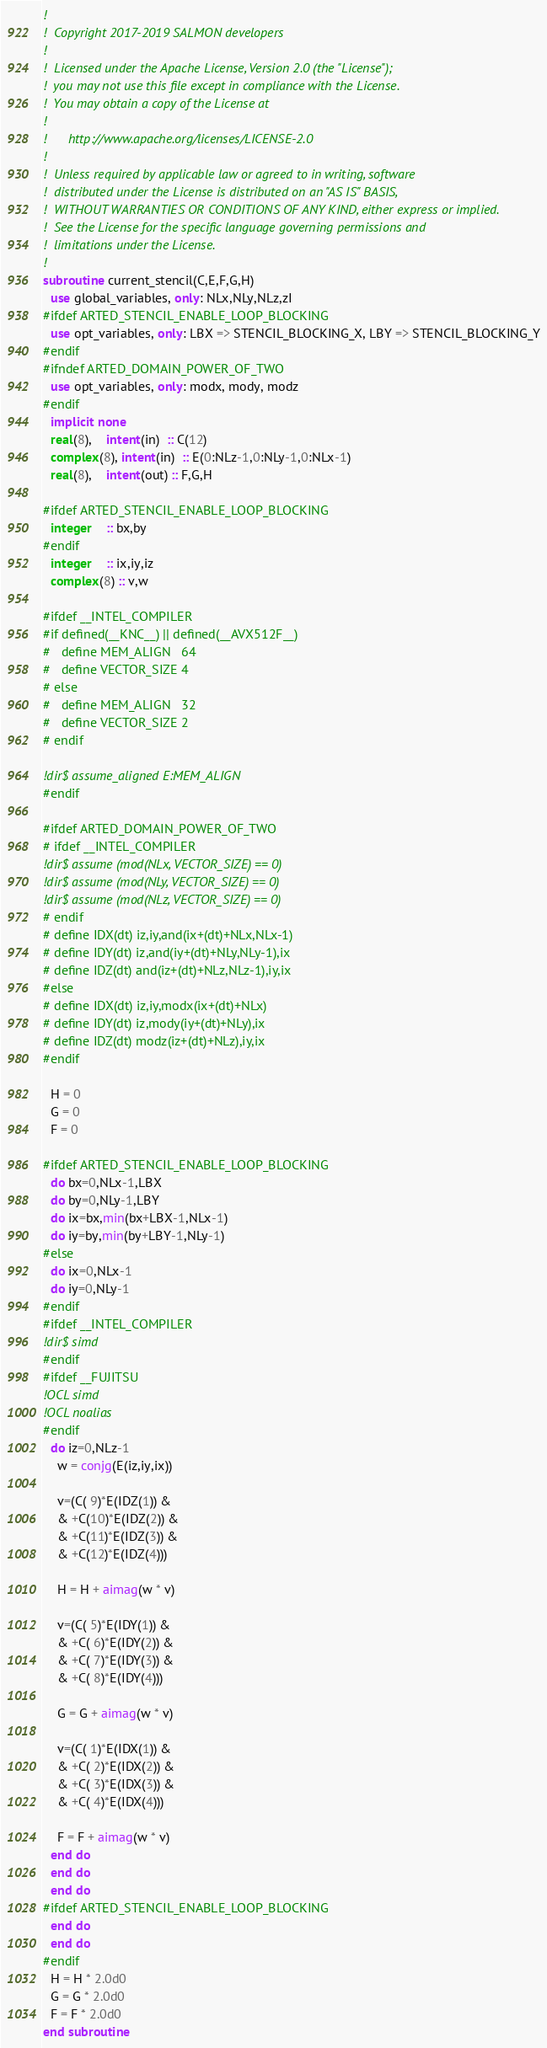Convert code to text. <code><loc_0><loc_0><loc_500><loc_500><_FORTRAN_>!
!  Copyright 2017-2019 SALMON developers
!
!  Licensed under the Apache License, Version 2.0 (the "License");
!  you may not use this file except in compliance with the License.
!  You may obtain a copy of the License at
!
!      http://www.apache.org/licenses/LICENSE-2.0
!
!  Unless required by applicable law or agreed to in writing, software
!  distributed under the License is distributed on an "AS IS" BASIS,
!  WITHOUT WARRANTIES OR CONDITIONS OF ANY KIND, either express or implied.
!  See the License for the specific language governing permissions and
!  limitations under the License.
!
subroutine current_stencil(C,E,F,G,H)
  use global_variables, only: NLx,NLy,NLz,zI
#ifdef ARTED_STENCIL_ENABLE_LOOP_BLOCKING
  use opt_variables, only: LBX => STENCIL_BLOCKING_X, LBY => STENCIL_BLOCKING_Y
#endif
#ifndef ARTED_DOMAIN_POWER_OF_TWO
  use opt_variables, only: modx, mody, modz
#endif
  implicit none
  real(8),    intent(in)  :: C(12)
  complex(8), intent(in)  :: E(0:NLz-1,0:NLy-1,0:NLx-1)
  real(8),    intent(out) :: F,G,H

#ifdef ARTED_STENCIL_ENABLE_LOOP_BLOCKING
  integer    :: bx,by
#endif
  integer    :: ix,iy,iz
  complex(8) :: v,w

#ifdef __INTEL_COMPILER
#if defined(__KNC__) || defined(__AVX512F__)
#   define MEM_ALIGN   64
#   define VECTOR_SIZE 4
# else
#   define MEM_ALIGN   32
#   define VECTOR_SIZE 2
# endif

!dir$ assume_aligned E:MEM_ALIGN
#endif

#ifdef ARTED_DOMAIN_POWER_OF_TWO
# ifdef __INTEL_COMPILER
!dir$ assume (mod(NLx, VECTOR_SIZE) == 0)
!dir$ assume (mod(NLy, VECTOR_SIZE) == 0)
!dir$ assume (mod(NLz, VECTOR_SIZE) == 0)
# endif
# define IDX(dt) iz,iy,and(ix+(dt)+NLx,NLx-1)
# define IDY(dt) iz,and(iy+(dt)+NLy,NLy-1),ix
# define IDZ(dt) and(iz+(dt)+NLz,NLz-1),iy,ix
#else
# define IDX(dt) iz,iy,modx(ix+(dt)+NLx)
# define IDY(dt) iz,mody(iy+(dt)+NLy),ix
# define IDZ(dt) modz(iz+(dt)+NLz),iy,ix
#endif

  H = 0
  G = 0
  F = 0

#ifdef ARTED_STENCIL_ENABLE_LOOP_BLOCKING
  do bx=0,NLx-1,LBX
  do by=0,NLy-1,LBY
  do ix=bx,min(bx+LBX-1,NLx-1)
  do iy=by,min(by+LBY-1,NLy-1)
#else
  do ix=0,NLx-1
  do iy=0,NLy-1
#endif
#ifdef __INTEL_COMPILER
!dir$ simd
#endif
#ifdef __FUJITSU
!OCL simd
!OCL noalias
#endif
  do iz=0,NLz-1
    w = conjg(E(iz,iy,ix))

    v=(C( 9)*E(IDZ(1)) &
    & +C(10)*E(IDZ(2)) &
    & +C(11)*E(IDZ(3)) &
    & +C(12)*E(IDZ(4)))

    H = H + aimag(w * v)

    v=(C( 5)*E(IDY(1)) &
    & +C( 6)*E(IDY(2)) &
    & +C( 7)*E(IDY(3)) &
    & +C( 8)*E(IDY(4)))

    G = G + aimag(w * v)

    v=(C( 1)*E(IDX(1)) &
    & +C( 2)*E(IDX(2)) &
    & +C( 3)*E(IDX(3)) &
    & +C( 4)*E(IDX(4)))

    F = F + aimag(w * v)
  end do
  end do
  end do
#ifdef ARTED_STENCIL_ENABLE_LOOP_BLOCKING
  end do
  end do
#endif
  H = H * 2.0d0
  G = G * 2.0d0
  F = F * 2.0d0
end subroutine
</code> 